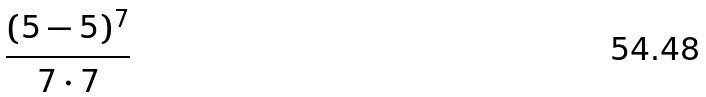Convert formula to latex. <formula><loc_0><loc_0><loc_500><loc_500>\frac { ( 5 - 5 ) ^ { 7 } } { 7 \cdot 7 }</formula> 